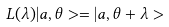<formula> <loc_0><loc_0><loc_500><loc_500>L ( \lambda ) | a , \theta > = | a , \theta + \lambda ></formula> 